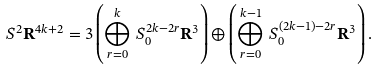Convert formula to latex. <formula><loc_0><loc_0><loc_500><loc_500>S ^ { 2 } \mathbf R ^ { 4 k + 2 } = 3 \left ( \bigoplus _ { r = 0 } ^ { k } \, S ^ { 2 k - 2 r } _ { 0 } \mathbf R ^ { 3 } \right ) \oplus \left ( \bigoplus _ { r = 0 } ^ { k - 1 } \, S ^ { ( 2 k - 1 ) - 2 r } _ { 0 } \mathbf R ^ { 3 } \right ) .</formula> 